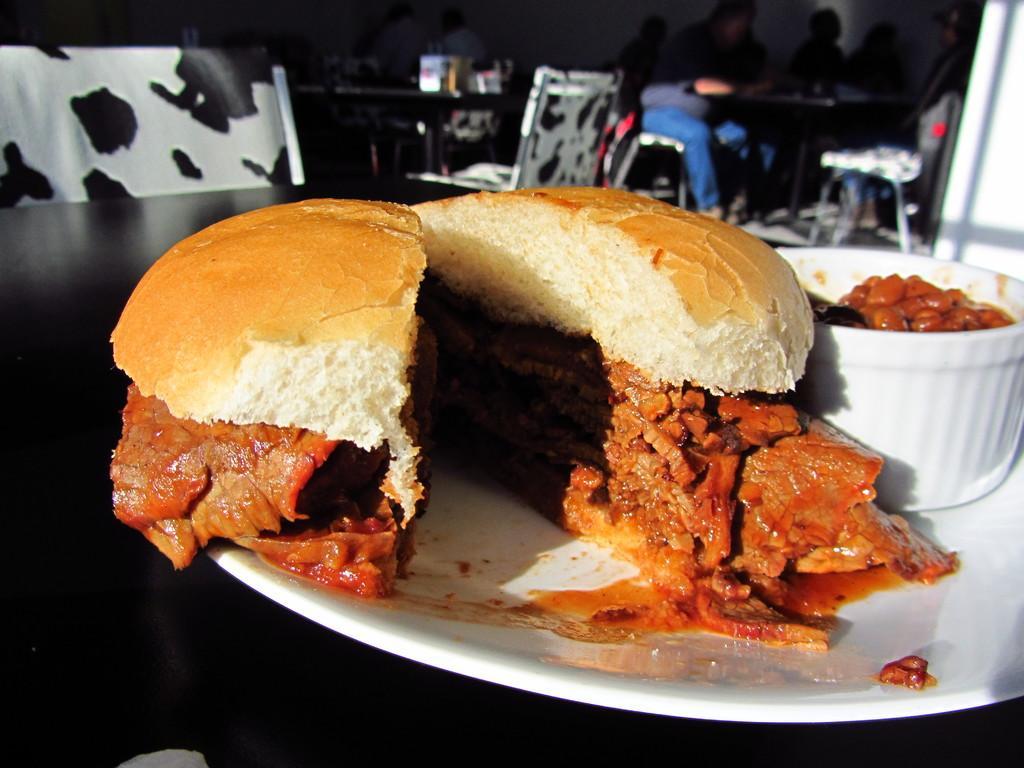In one or two sentences, can you explain what this image depicts? In the foreground of the image we can see food and bowl placed on a plate on the table. In the background, we can see a group of people sitting on chairs and group of tables on the floor. 